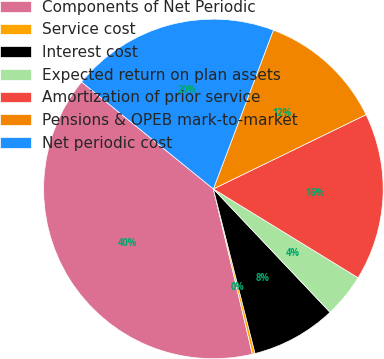Convert chart. <chart><loc_0><loc_0><loc_500><loc_500><pie_chart><fcel>Components of Net Periodic<fcel>Service cost<fcel>Interest cost<fcel>Expected return on plan assets<fcel>Amortization of prior service<fcel>Pensions & OPEB mark-to-market<fcel>Net periodic cost<nl><fcel>39.54%<fcel>0.26%<fcel>8.11%<fcel>4.18%<fcel>15.97%<fcel>12.04%<fcel>19.9%<nl></chart> 